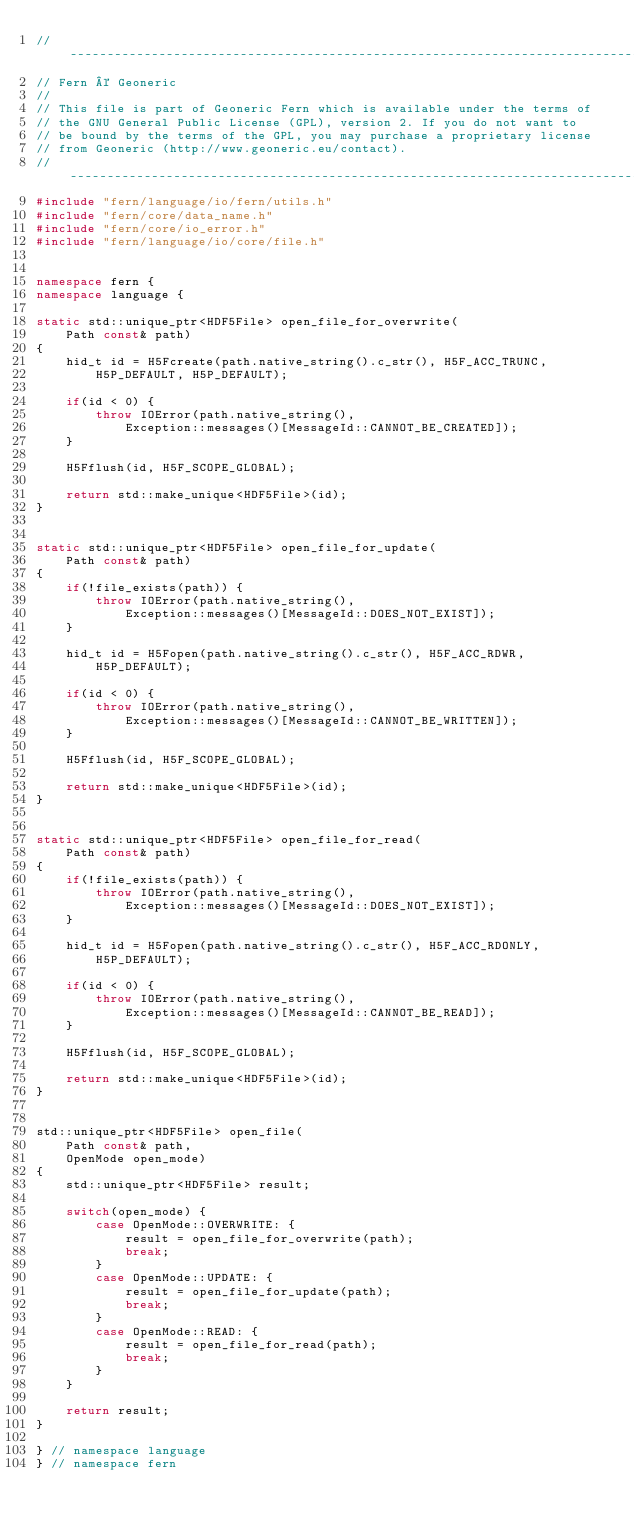Convert code to text. <code><loc_0><loc_0><loc_500><loc_500><_C++_>// -----------------------------------------------------------------------------
// Fern © Geoneric
//
// This file is part of Geoneric Fern which is available under the terms of
// the GNU General Public License (GPL), version 2. If you do not want to
// be bound by the terms of the GPL, you may purchase a proprietary license
// from Geoneric (http://www.geoneric.eu/contact).
// -----------------------------------------------------------------------------
#include "fern/language/io/fern/utils.h"
#include "fern/core/data_name.h"
#include "fern/core/io_error.h"
#include "fern/language/io/core/file.h"


namespace fern {
namespace language {

static std::unique_ptr<HDF5File> open_file_for_overwrite(
    Path const& path)
{
    hid_t id = H5Fcreate(path.native_string().c_str(), H5F_ACC_TRUNC,
        H5P_DEFAULT, H5P_DEFAULT);

    if(id < 0) {
        throw IOError(path.native_string(),
            Exception::messages()[MessageId::CANNOT_BE_CREATED]);
    }

    H5Fflush(id, H5F_SCOPE_GLOBAL);

    return std::make_unique<HDF5File>(id);
}


static std::unique_ptr<HDF5File> open_file_for_update(
    Path const& path)
{
    if(!file_exists(path)) {
        throw IOError(path.native_string(),
            Exception::messages()[MessageId::DOES_NOT_EXIST]);
    }

    hid_t id = H5Fopen(path.native_string().c_str(), H5F_ACC_RDWR,
        H5P_DEFAULT);

    if(id < 0) {
        throw IOError(path.native_string(),
            Exception::messages()[MessageId::CANNOT_BE_WRITTEN]);
    }

    H5Fflush(id, H5F_SCOPE_GLOBAL);

    return std::make_unique<HDF5File>(id);
}


static std::unique_ptr<HDF5File> open_file_for_read(
    Path const& path)
{
    if(!file_exists(path)) {
        throw IOError(path.native_string(),
            Exception::messages()[MessageId::DOES_NOT_EXIST]);
    }

    hid_t id = H5Fopen(path.native_string().c_str(), H5F_ACC_RDONLY,
        H5P_DEFAULT);

    if(id < 0) {
        throw IOError(path.native_string(),
            Exception::messages()[MessageId::CANNOT_BE_READ]);
    }

    H5Fflush(id, H5F_SCOPE_GLOBAL);

    return std::make_unique<HDF5File>(id);
}


std::unique_ptr<HDF5File> open_file(
    Path const& path,
    OpenMode open_mode)
{
    std::unique_ptr<HDF5File> result;

    switch(open_mode) {
        case OpenMode::OVERWRITE: {
            result = open_file_for_overwrite(path);
            break;
        }
        case OpenMode::UPDATE: {
            result = open_file_for_update(path);
            break;
        }
        case OpenMode::READ: {
            result = open_file_for_read(path);
            break;
        }
    }

    return result;
}

} // namespace language
} // namespace fern
</code> 